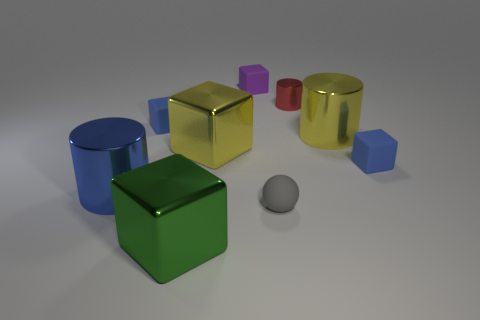Subtract all tiny blue matte cubes. How many cubes are left? 3 Add 1 big cyan shiny things. How many objects exist? 10 Subtract all red cylinders. How many blue blocks are left? 2 Subtract 1 cubes. How many cubes are left? 4 Subtract all cubes. How many objects are left? 4 Subtract all yellow cylinders. How many cylinders are left? 2 Subtract all small matte cubes. Subtract all blue cylinders. How many objects are left? 5 Add 7 blue matte things. How many blue matte things are left? 9 Add 8 large blue matte things. How many large blue matte things exist? 8 Subtract 1 blue cubes. How many objects are left? 8 